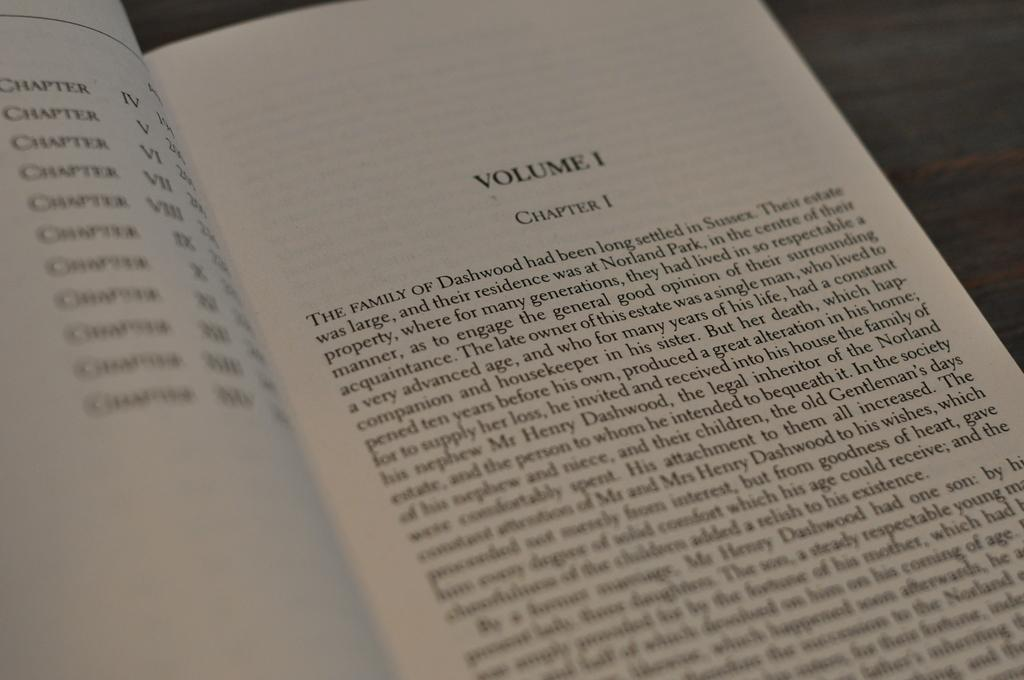<image>
Offer a succinct explanation of the picture presented. First page of chapter one of volume 1 of the book. 